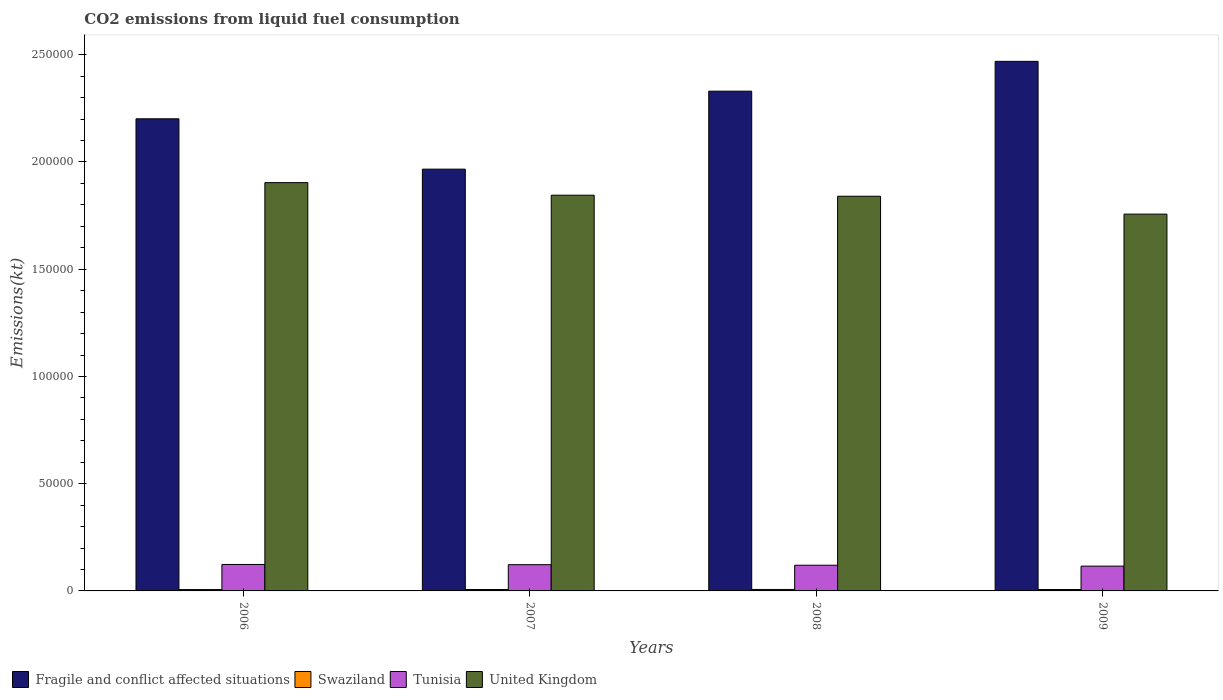How many groups of bars are there?
Give a very brief answer. 4. Are the number of bars on each tick of the X-axis equal?
Your answer should be compact. Yes. How many bars are there on the 2nd tick from the left?
Your answer should be compact. 4. What is the amount of CO2 emitted in Tunisia in 2006?
Offer a very short reply. 1.23e+04. Across all years, what is the maximum amount of CO2 emitted in Tunisia?
Give a very brief answer. 1.23e+04. Across all years, what is the minimum amount of CO2 emitted in Tunisia?
Keep it short and to the point. 1.16e+04. In which year was the amount of CO2 emitted in Swaziland maximum?
Make the answer very short. 2008. What is the total amount of CO2 emitted in Swaziland in the graph?
Your answer should be compact. 2640.24. What is the difference between the amount of CO2 emitted in United Kingdom in 2006 and that in 2007?
Provide a short and direct response. 5859.87. What is the difference between the amount of CO2 emitted in United Kingdom in 2009 and the amount of CO2 emitted in Tunisia in 2006?
Make the answer very short. 1.63e+05. What is the average amount of CO2 emitted in Fragile and conflict affected situations per year?
Make the answer very short. 2.24e+05. In the year 2007, what is the difference between the amount of CO2 emitted in Swaziland and amount of CO2 emitted in Tunisia?
Your response must be concise. -1.16e+04. What is the ratio of the amount of CO2 emitted in Tunisia in 2006 to that in 2008?
Your answer should be compact. 1.03. Is the difference between the amount of CO2 emitted in Swaziland in 2006 and 2008 greater than the difference between the amount of CO2 emitted in Tunisia in 2006 and 2008?
Make the answer very short. No. What is the difference between the highest and the second highest amount of CO2 emitted in Fragile and conflict affected situations?
Your response must be concise. 1.39e+04. What is the difference between the highest and the lowest amount of CO2 emitted in Tunisia?
Offer a very short reply. 773.74. In how many years, is the amount of CO2 emitted in United Kingdom greater than the average amount of CO2 emitted in United Kingdom taken over all years?
Offer a very short reply. 3. Is the sum of the amount of CO2 emitted in Fragile and conflict affected situations in 2006 and 2009 greater than the maximum amount of CO2 emitted in United Kingdom across all years?
Ensure brevity in your answer.  Yes. What does the 2nd bar from the left in 2009 represents?
Your answer should be very brief. Swaziland. Is it the case that in every year, the sum of the amount of CO2 emitted in Tunisia and amount of CO2 emitted in Swaziland is greater than the amount of CO2 emitted in Fragile and conflict affected situations?
Keep it short and to the point. No. Are all the bars in the graph horizontal?
Ensure brevity in your answer.  No. Are the values on the major ticks of Y-axis written in scientific E-notation?
Offer a terse response. No. Does the graph contain any zero values?
Make the answer very short. No. Does the graph contain grids?
Offer a very short reply. No. Where does the legend appear in the graph?
Your answer should be compact. Bottom left. How are the legend labels stacked?
Ensure brevity in your answer.  Horizontal. What is the title of the graph?
Make the answer very short. CO2 emissions from liquid fuel consumption. Does "Congo (Republic)" appear as one of the legend labels in the graph?
Ensure brevity in your answer.  No. What is the label or title of the Y-axis?
Your answer should be very brief. Emissions(kt). What is the Emissions(kt) in Fragile and conflict affected situations in 2006?
Make the answer very short. 2.20e+05. What is the Emissions(kt) of Swaziland in 2006?
Your answer should be compact. 630.72. What is the Emissions(kt) of Tunisia in 2006?
Ensure brevity in your answer.  1.23e+04. What is the Emissions(kt) of United Kingdom in 2006?
Provide a short and direct response. 1.90e+05. What is the Emissions(kt) in Fragile and conflict affected situations in 2007?
Make the answer very short. 1.97e+05. What is the Emissions(kt) of Swaziland in 2007?
Offer a very short reply. 663.73. What is the Emissions(kt) of Tunisia in 2007?
Ensure brevity in your answer.  1.22e+04. What is the Emissions(kt) of United Kingdom in 2007?
Give a very brief answer. 1.85e+05. What is the Emissions(kt) of Fragile and conflict affected situations in 2008?
Make the answer very short. 2.33e+05. What is the Emissions(kt) of Swaziland in 2008?
Your answer should be compact. 682.06. What is the Emissions(kt) of Tunisia in 2008?
Your answer should be compact. 1.20e+04. What is the Emissions(kt) in United Kingdom in 2008?
Provide a short and direct response. 1.84e+05. What is the Emissions(kt) in Fragile and conflict affected situations in 2009?
Provide a succinct answer. 2.47e+05. What is the Emissions(kt) in Swaziland in 2009?
Keep it short and to the point. 663.73. What is the Emissions(kt) of Tunisia in 2009?
Provide a short and direct response. 1.16e+04. What is the Emissions(kt) of United Kingdom in 2009?
Ensure brevity in your answer.  1.76e+05. Across all years, what is the maximum Emissions(kt) in Fragile and conflict affected situations?
Offer a very short reply. 2.47e+05. Across all years, what is the maximum Emissions(kt) of Swaziland?
Make the answer very short. 682.06. Across all years, what is the maximum Emissions(kt) of Tunisia?
Your answer should be very brief. 1.23e+04. Across all years, what is the maximum Emissions(kt) in United Kingdom?
Keep it short and to the point. 1.90e+05. Across all years, what is the minimum Emissions(kt) of Fragile and conflict affected situations?
Offer a terse response. 1.97e+05. Across all years, what is the minimum Emissions(kt) in Swaziland?
Your answer should be very brief. 630.72. Across all years, what is the minimum Emissions(kt) of Tunisia?
Ensure brevity in your answer.  1.16e+04. Across all years, what is the minimum Emissions(kt) in United Kingdom?
Give a very brief answer. 1.76e+05. What is the total Emissions(kt) of Fragile and conflict affected situations in the graph?
Make the answer very short. 8.97e+05. What is the total Emissions(kt) of Swaziland in the graph?
Offer a terse response. 2640.24. What is the total Emissions(kt) in Tunisia in the graph?
Give a very brief answer. 4.81e+04. What is the total Emissions(kt) of United Kingdom in the graph?
Provide a succinct answer. 7.35e+05. What is the difference between the Emissions(kt) in Fragile and conflict affected situations in 2006 and that in 2007?
Give a very brief answer. 2.35e+04. What is the difference between the Emissions(kt) in Swaziland in 2006 and that in 2007?
Your response must be concise. -33. What is the difference between the Emissions(kt) in Tunisia in 2006 and that in 2007?
Offer a terse response. 102.68. What is the difference between the Emissions(kt) in United Kingdom in 2006 and that in 2007?
Your answer should be very brief. 5859.87. What is the difference between the Emissions(kt) of Fragile and conflict affected situations in 2006 and that in 2008?
Your answer should be very brief. -1.29e+04. What is the difference between the Emissions(kt) in Swaziland in 2006 and that in 2008?
Keep it short and to the point. -51.34. What is the difference between the Emissions(kt) in Tunisia in 2006 and that in 2008?
Your response must be concise. 355.7. What is the difference between the Emissions(kt) of United Kingdom in 2006 and that in 2008?
Make the answer very short. 6351.24. What is the difference between the Emissions(kt) of Fragile and conflict affected situations in 2006 and that in 2009?
Offer a terse response. -2.68e+04. What is the difference between the Emissions(kt) of Swaziland in 2006 and that in 2009?
Provide a short and direct response. -33. What is the difference between the Emissions(kt) in Tunisia in 2006 and that in 2009?
Ensure brevity in your answer.  773.74. What is the difference between the Emissions(kt) of United Kingdom in 2006 and that in 2009?
Keep it short and to the point. 1.47e+04. What is the difference between the Emissions(kt) of Fragile and conflict affected situations in 2007 and that in 2008?
Offer a terse response. -3.64e+04. What is the difference between the Emissions(kt) in Swaziland in 2007 and that in 2008?
Your response must be concise. -18.34. What is the difference between the Emissions(kt) of Tunisia in 2007 and that in 2008?
Your answer should be very brief. 253.02. What is the difference between the Emissions(kt) in United Kingdom in 2007 and that in 2008?
Make the answer very short. 491.38. What is the difference between the Emissions(kt) in Fragile and conflict affected situations in 2007 and that in 2009?
Offer a very short reply. -5.03e+04. What is the difference between the Emissions(kt) of Swaziland in 2007 and that in 2009?
Offer a terse response. 0. What is the difference between the Emissions(kt) of Tunisia in 2007 and that in 2009?
Your answer should be very brief. 671.06. What is the difference between the Emissions(kt) in United Kingdom in 2007 and that in 2009?
Your answer should be compact. 8826.47. What is the difference between the Emissions(kt) in Fragile and conflict affected situations in 2008 and that in 2009?
Provide a succinct answer. -1.39e+04. What is the difference between the Emissions(kt) in Swaziland in 2008 and that in 2009?
Make the answer very short. 18.34. What is the difference between the Emissions(kt) of Tunisia in 2008 and that in 2009?
Offer a very short reply. 418.04. What is the difference between the Emissions(kt) of United Kingdom in 2008 and that in 2009?
Offer a terse response. 8335.09. What is the difference between the Emissions(kt) of Fragile and conflict affected situations in 2006 and the Emissions(kt) of Swaziland in 2007?
Your answer should be very brief. 2.19e+05. What is the difference between the Emissions(kt) in Fragile and conflict affected situations in 2006 and the Emissions(kt) in Tunisia in 2007?
Provide a succinct answer. 2.08e+05. What is the difference between the Emissions(kt) of Fragile and conflict affected situations in 2006 and the Emissions(kt) of United Kingdom in 2007?
Ensure brevity in your answer.  3.56e+04. What is the difference between the Emissions(kt) of Swaziland in 2006 and the Emissions(kt) of Tunisia in 2007?
Provide a short and direct response. -1.16e+04. What is the difference between the Emissions(kt) of Swaziland in 2006 and the Emissions(kt) of United Kingdom in 2007?
Ensure brevity in your answer.  -1.84e+05. What is the difference between the Emissions(kt) of Tunisia in 2006 and the Emissions(kt) of United Kingdom in 2007?
Make the answer very short. -1.72e+05. What is the difference between the Emissions(kt) in Fragile and conflict affected situations in 2006 and the Emissions(kt) in Swaziland in 2008?
Your answer should be very brief. 2.19e+05. What is the difference between the Emissions(kt) of Fragile and conflict affected situations in 2006 and the Emissions(kt) of Tunisia in 2008?
Make the answer very short. 2.08e+05. What is the difference between the Emissions(kt) in Fragile and conflict affected situations in 2006 and the Emissions(kt) in United Kingdom in 2008?
Make the answer very short. 3.61e+04. What is the difference between the Emissions(kt) in Swaziland in 2006 and the Emissions(kt) in Tunisia in 2008?
Your response must be concise. -1.13e+04. What is the difference between the Emissions(kt) in Swaziland in 2006 and the Emissions(kt) in United Kingdom in 2008?
Offer a very short reply. -1.83e+05. What is the difference between the Emissions(kt) of Tunisia in 2006 and the Emissions(kt) of United Kingdom in 2008?
Make the answer very short. -1.72e+05. What is the difference between the Emissions(kt) of Fragile and conflict affected situations in 2006 and the Emissions(kt) of Swaziland in 2009?
Your response must be concise. 2.19e+05. What is the difference between the Emissions(kt) of Fragile and conflict affected situations in 2006 and the Emissions(kt) of Tunisia in 2009?
Ensure brevity in your answer.  2.09e+05. What is the difference between the Emissions(kt) in Fragile and conflict affected situations in 2006 and the Emissions(kt) in United Kingdom in 2009?
Ensure brevity in your answer.  4.44e+04. What is the difference between the Emissions(kt) in Swaziland in 2006 and the Emissions(kt) in Tunisia in 2009?
Offer a terse response. -1.09e+04. What is the difference between the Emissions(kt) of Swaziland in 2006 and the Emissions(kt) of United Kingdom in 2009?
Keep it short and to the point. -1.75e+05. What is the difference between the Emissions(kt) in Tunisia in 2006 and the Emissions(kt) in United Kingdom in 2009?
Provide a succinct answer. -1.63e+05. What is the difference between the Emissions(kt) of Fragile and conflict affected situations in 2007 and the Emissions(kt) of Swaziland in 2008?
Offer a terse response. 1.96e+05. What is the difference between the Emissions(kt) of Fragile and conflict affected situations in 2007 and the Emissions(kt) of Tunisia in 2008?
Your answer should be compact. 1.85e+05. What is the difference between the Emissions(kt) in Fragile and conflict affected situations in 2007 and the Emissions(kt) in United Kingdom in 2008?
Offer a very short reply. 1.26e+04. What is the difference between the Emissions(kt) of Swaziland in 2007 and the Emissions(kt) of Tunisia in 2008?
Give a very brief answer. -1.13e+04. What is the difference between the Emissions(kt) in Swaziland in 2007 and the Emissions(kt) in United Kingdom in 2008?
Make the answer very short. -1.83e+05. What is the difference between the Emissions(kt) in Tunisia in 2007 and the Emissions(kt) in United Kingdom in 2008?
Your response must be concise. -1.72e+05. What is the difference between the Emissions(kt) in Fragile and conflict affected situations in 2007 and the Emissions(kt) in Swaziland in 2009?
Your answer should be compact. 1.96e+05. What is the difference between the Emissions(kt) of Fragile and conflict affected situations in 2007 and the Emissions(kt) of Tunisia in 2009?
Provide a succinct answer. 1.85e+05. What is the difference between the Emissions(kt) of Fragile and conflict affected situations in 2007 and the Emissions(kt) of United Kingdom in 2009?
Offer a terse response. 2.10e+04. What is the difference between the Emissions(kt) in Swaziland in 2007 and the Emissions(kt) in Tunisia in 2009?
Give a very brief answer. -1.09e+04. What is the difference between the Emissions(kt) in Swaziland in 2007 and the Emissions(kt) in United Kingdom in 2009?
Provide a short and direct response. -1.75e+05. What is the difference between the Emissions(kt) in Tunisia in 2007 and the Emissions(kt) in United Kingdom in 2009?
Give a very brief answer. -1.63e+05. What is the difference between the Emissions(kt) in Fragile and conflict affected situations in 2008 and the Emissions(kt) in Swaziland in 2009?
Keep it short and to the point. 2.32e+05. What is the difference between the Emissions(kt) of Fragile and conflict affected situations in 2008 and the Emissions(kt) of Tunisia in 2009?
Your response must be concise. 2.21e+05. What is the difference between the Emissions(kt) in Fragile and conflict affected situations in 2008 and the Emissions(kt) in United Kingdom in 2009?
Ensure brevity in your answer.  5.73e+04. What is the difference between the Emissions(kt) in Swaziland in 2008 and the Emissions(kt) in Tunisia in 2009?
Offer a terse response. -1.09e+04. What is the difference between the Emissions(kt) of Swaziland in 2008 and the Emissions(kt) of United Kingdom in 2009?
Provide a succinct answer. -1.75e+05. What is the difference between the Emissions(kt) of Tunisia in 2008 and the Emissions(kt) of United Kingdom in 2009?
Make the answer very short. -1.64e+05. What is the average Emissions(kt) in Fragile and conflict affected situations per year?
Keep it short and to the point. 2.24e+05. What is the average Emissions(kt) in Swaziland per year?
Ensure brevity in your answer.  660.06. What is the average Emissions(kt) in Tunisia per year?
Give a very brief answer. 1.20e+04. What is the average Emissions(kt) of United Kingdom per year?
Make the answer very short. 1.84e+05. In the year 2006, what is the difference between the Emissions(kt) of Fragile and conflict affected situations and Emissions(kt) of Swaziland?
Make the answer very short. 2.20e+05. In the year 2006, what is the difference between the Emissions(kt) of Fragile and conflict affected situations and Emissions(kt) of Tunisia?
Give a very brief answer. 2.08e+05. In the year 2006, what is the difference between the Emissions(kt) in Fragile and conflict affected situations and Emissions(kt) in United Kingdom?
Give a very brief answer. 2.98e+04. In the year 2006, what is the difference between the Emissions(kt) in Swaziland and Emissions(kt) in Tunisia?
Your answer should be very brief. -1.17e+04. In the year 2006, what is the difference between the Emissions(kt) of Swaziland and Emissions(kt) of United Kingdom?
Provide a short and direct response. -1.90e+05. In the year 2006, what is the difference between the Emissions(kt) in Tunisia and Emissions(kt) in United Kingdom?
Your response must be concise. -1.78e+05. In the year 2007, what is the difference between the Emissions(kt) in Fragile and conflict affected situations and Emissions(kt) in Swaziland?
Provide a short and direct response. 1.96e+05. In the year 2007, what is the difference between the Emissions(kt) of Fragile and conflict affected situations and Emissions(kt) of Tunisia?
Offer a terse response. 1.84e+05. In the year 2007, what is the difference between the Emissions(kt) of Fragile and conflict affected situations and Emissions(kt) of United Kingdom?
Your answer should be very brief. 1.21e+04. In the year 2007, what is the difference between the Emissions(kt) of Swaziland and Emissions(kt) of Tunisia?
Make the answer very short. -1.16e+04. In the year 2007, what is the difference between the Emissions(kt) of Swaziland and Emissions(kt) of United Kingdom?
Make the answer very short. -1.84e+05. In the year 2007, what is the difference between the Emissions(kt) in Tunisia and Emissions(kt) in United Kingdom?
Keep it short and to the point. -1.72e+05. In the year 2008, what is the difference between the Emissions(kt) in Fragile and conflict affected situations and Emissions(kt) in Swaziland?
Ensure brevity in your answer.  2.32e+05. In the year 2008, what is the difference between the Emissions(kt) of Fragile and conflict affected situations and Emissions(kt) of Tunisia?
Offer a very short reply. 2.21e+05. In the year 2008, what is the difference between the Emissions(kt) in Fragile and conflict affected situations and Emissions(kt) in United Kingdom?
Offer a very short reply. 4.90e+04. In the year 2008, what is the difference between the Emissions(kt) in Swaziland and Emissions(kt) in Tunisia?
Keep it short and to the point. -1.13e+04. In the year 2008, what is the difference between the Emissions(kt) of Swaziland and Emissions(kt) of United Kingdom?
Provide a succinct answer. -1.83e+05. In the year 2008, what is the difference between the Emissions(kt) in Tunisia and Emissions(kt) in United Kingdom?
Make the answer very short. -1.72e+05. In the year 2009, what is the difference between the Emissions(kt) of Fragile and conflict affected situations and Emissions(kt) of Swaziland?
Provide a short and direct response. 2.46e+05. In the year 2009, what is the difference between the Emissions(kt) in Fragile and conflict affected situations and Emissions(kt) in Tunisia?
Keep it short and to the point. 2.35e+05. In the year 2009, what is the difference between the Emissions(kt) in Fragile and conflict affected situations and Emissions(kt) in United Kingdom?
Offer a very short reply. 7.12e+04. In the year 2009, what is the difference between the Emissions(kt) in Swaziland and Emissions(kt) in Tunisia?
Provide a succinct answer. -1.09e+04. In the year 2009, what is the difference between the Emissions(kt) in Swaziland and Emissions(kt) in United Kingdom?
Ensure brevity in your answer.  -1.75e+05. In the year 2009, what is the difference between the Emissions(kt) of Tunisia and Emissions(kt) of United Kingdom?
Ensure brevity in your answer.  -1.64e+05. What is the ratio of the Emissions(kt) of Fragile and conflict affected situations in 2006 to that in 2007?
Offer a terse response. 1.12. What is the ratio of the Emissions(kt) of Swaziland in 2006 to that in 2007?
Your answer should be very brief. 0.95. What is the ratio of the Emissions(kt) of Tunisia in 2006 to that in 2007?
Your answer should be very brief. 1.01. What is the ratio of the Emissions(kt) of United Kingdom in 2006 to that in 2007?
Your answer should be very brief. 1.03. What is the ratio of the Emissions(kt) in Fragile and conflict affected situations in 2006 to that in 2008?
Offer a very short reply. 0.94. What is the ratio of the Emissions(kt) of Swaziland in 2006 to that in 2008?
Keep it short and to the point. 0.92. What is the ratio of the Emissions(kt) of Tunisia in 2006 to that in 2008?
Your answer should be very brief. 1.03. What is the ratio of the Emissions(kt) of United Kingdom in 2006 to that in 2008?
Your answer should be very brief. 1.03. What is the ratio of the Emissions(kt) of Fragile and conflict affected situations in 2006 to that in 2009?
Give a very brief answer. 0.89. What is the ratio of the Emissions(kt) of Swaziland in 2006 to that in 2009?
Provide a short and direct response. 0.95. What is the ratio of the Emissions(kt) of Tunisia in 2006 to that in 2009?
Offer a terse response. 1.07. What is the ratio of the Emissions(kt) in United Kingdom in 2006 to that in 2009?
Provide a succinct answer. 1.08. What is the ratio of the Emissions(kt) in Fragile and conflict affected situations in 2007 to that in 2008?
Your answer should be very brief. 0.84. What is the ratio of the Emissions(kt) of Swaziland in 2007 to that in 2008?
Your answer should be very brief. 0.97. What is the ratio of the Emissions(kt) of Tunisia in 2007 to that in 2008?
Provide a succinct answer. 1.02. What is the ratio of the Emissions(kt) in United Kingdom in 2007 to that in 2008?
Provide a short and direct response. 1. What is the ratio of the Emissions(kt) of Fragile and conflict affected situations in 2007 to that in 2009?
Offer a terse response. 0.8. What is the ratio of the Emissions(kt) in Tunisia in 2007 to that in 2009?
Your answer should be compact. 1.06. What is the ratio of the Emissions(kt) of United Kingdom in 2007 to that in 2009?
Your response must be concise. 1.05. What is the ratio of the Emissions(kt) of Fragile and conflict affected situations in 2008 to that in 2009?
Offer a terse response. 0.94. What is the ratio of the Emissions(kt) in Swaziland in 2008 to that in 2009?
Provide a succinct answer. 1.03. What is the ratio of the Emissions(kt) in Tunisia in 2008 to that in 2009?
Offer a very short reply. 1.04. What is the ratio of the Emissions(kt) in United Kingdom in 2008 to that in 2009?
Make the answer very short. 1.05. What is the difference between the highest and the second highest Emissions(kt) of Fragile and conflict affected situations?
Offer a terse response. 1.39e+04. What is the difference between the highest and the second highest Emissions(kt) of Swaziland?
Your response must be concise. 18.34. What is the difference between the highest and the second highest Emissions(kt) of Tunisia?
Your answer should be very brief. 102.68. What is the difference between the highest and the second highest Emissions(kt) of United Kingdom?
Ensure brevity in your answer.  5859.87. What is the difference between the highest and the lowest Emissions(kt) of Fragile and conflict affected situations?
Provide a succinct answer. 5.03e+04. What is the difference between the highest and the lowest Emissions(kt) in Swaziland?
Offer a very short reply. 51.34. What is the difference between the highest and the lowest Emissions(kt) of Tunisia?
Make the answer very short. 773.74. What is the difference between the highest and the lowest Emissions(kt) in United Kingdom?
Provide a succinct answer. 1.47e+04. 